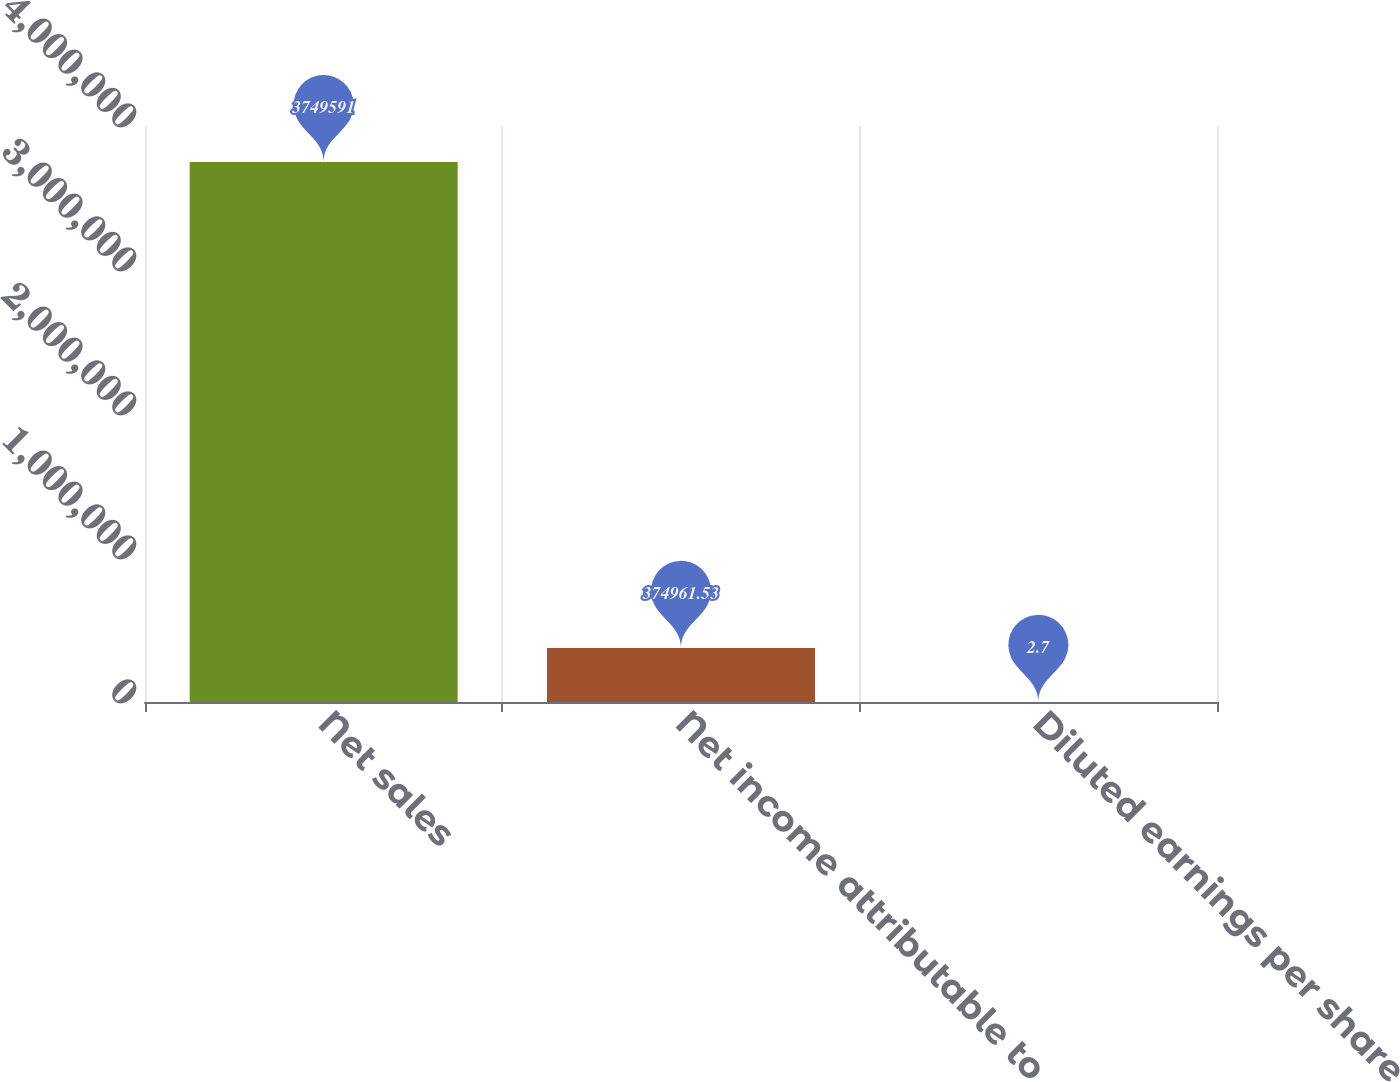<chart> <loc_0><loc_0><loc_500><loc_500><bar_chart><fcel>Net sales<fcel>Net income attributable to<fcel>Diluted earnings per share<nl><fcel>3.74959e+06<fcel>374962<fcel>2.7<nl></chart> 